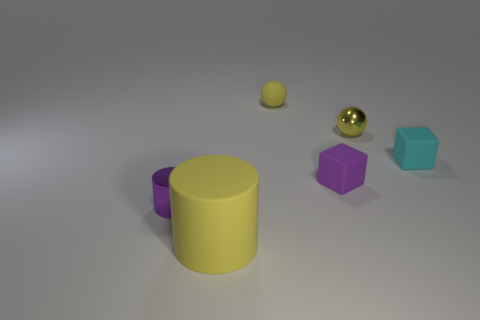Subtract all cyan blocks. How many blocks are left? 1 Subtract all cylinders. How many objects are left? 4 Add 2 large brown cylinders. How many objects exist? 8 Subtract 1 balls. How many balls are left? 1 Subtract all gray cylinders. How many purple cubes are left? 1 Add 2 tiny cylinders. How many tiny cylinders are left? 3 Add 4 yellow cylinders. How many yellow cylinders exist? 5 Subtract 1 cyan blocks. How many objects are left? 5 Subtract all cyan balls. Subtract all cyan cylinders. How many balls are left? 2 Subtract all big rubber things. Subtract all tiny metal things. How many objects are left? 3 